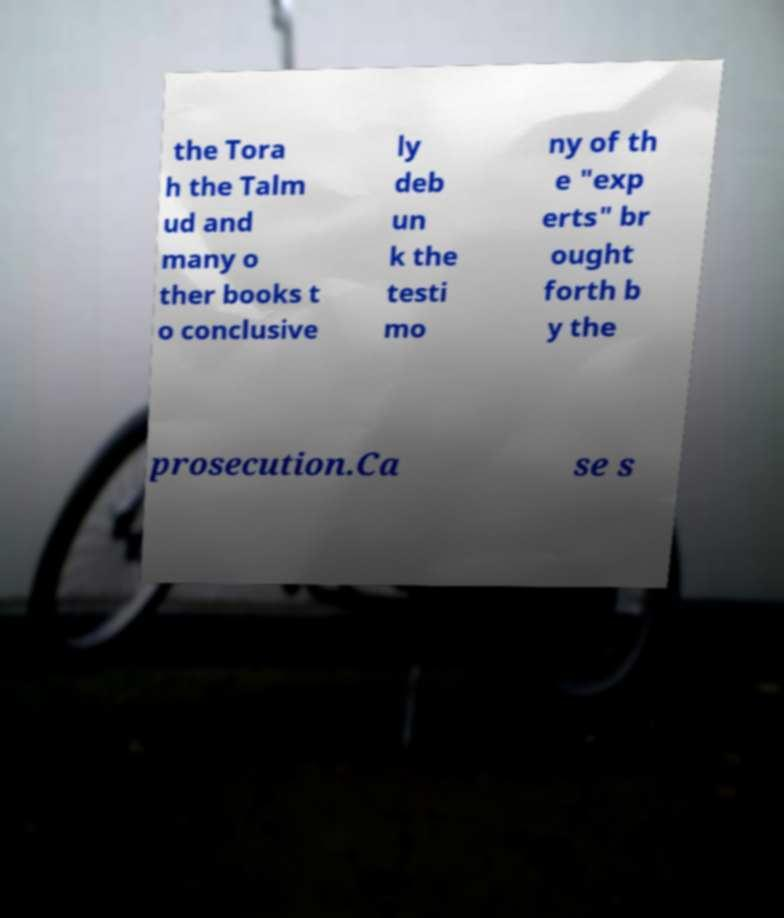Please identify and transcribe the text found in this image. the Tora h the Talm ud and many o ther books t o conclusive ly deb un k the testi mo ny of th e "exp erts" br ought forth b y the prosecution.Ca se s 